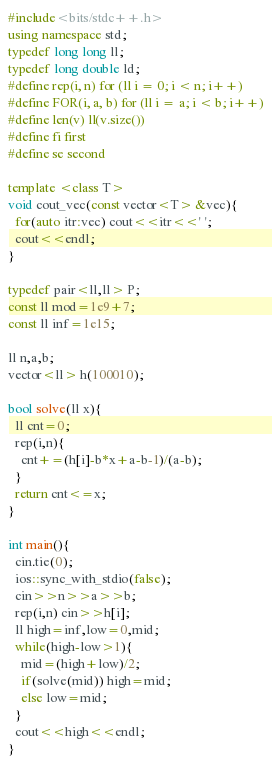<code> <loc_0><loc_0><loc_500><loc_500><_C++_>#include<bits/stdc++.h>
using namespace std;
typedef long long ll;
typedef long double ld;
#define rep(i, n) for (ll i = 0; i < n; i++)
#define FOR(i, a, b) for (ll i = a; i < b; i++)
#define len(v) ll(v.size())
#define fi first
#define se second

template <class T>
void cout_vec(const vector<T> &vec){
  for(auto itr:vec) cout<<itr<<' ';
  cout<<endl;
}

typedef pair<ll,ll> P;
const ll mod=1e9+7;
const ll inf=1e15;

ll n,a,b;
vector<ll> h(100010);

bool solve(ll x){
  ll cnt=0;
  rep(i,n){
    cnt+=(h[i]-b*x+a-b-1)/(a-b);
  }
  return cnt<=x;
}

int main(){
  cin.tie(0);
  ios::sync_with_stdio(false);
  cin>>n>>a>>b;
  rep(i,n) cin>>h[i];
  ll high=inf,low=0,mid;
  while(high-low>1){
    mid=(high+low)/2;
    if(solve(mid)) high=mid;
    else low=mid;
  }
  cout<<high<<endl;
}</code> 